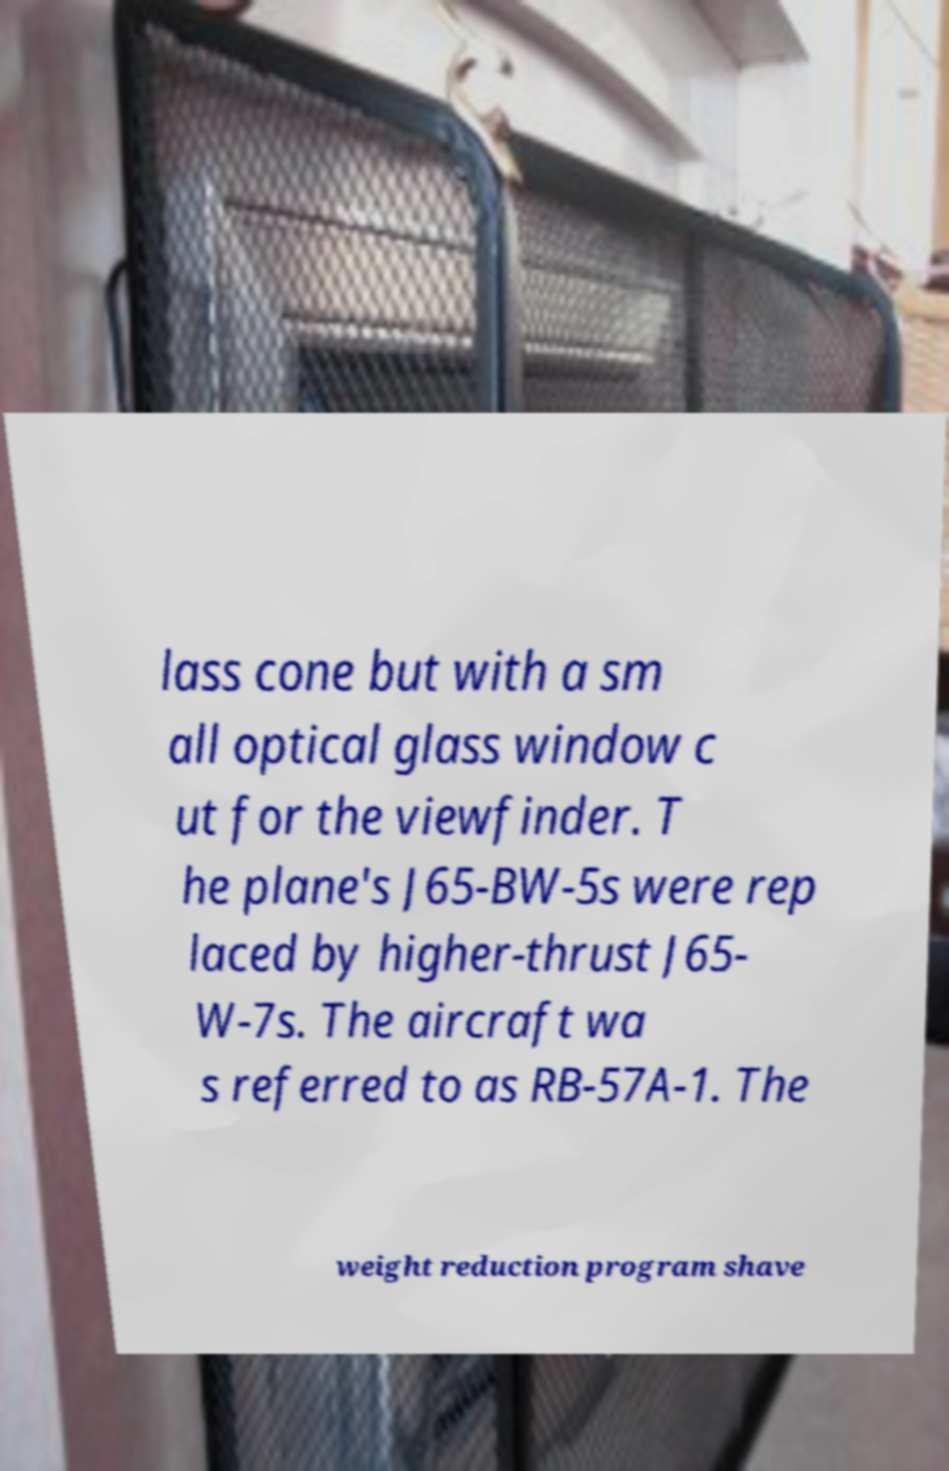For documentation purposes, I need the text within this image transcribed. Could you provide that? lass cone but with a sm all optical glass window c ut for the viewfinder. T he plane's J65-BW-5s were rep laced by higher-thrust J65- W-7s. The aircraft wa s referred to as RB-57A-1. The weight reduction program shave 